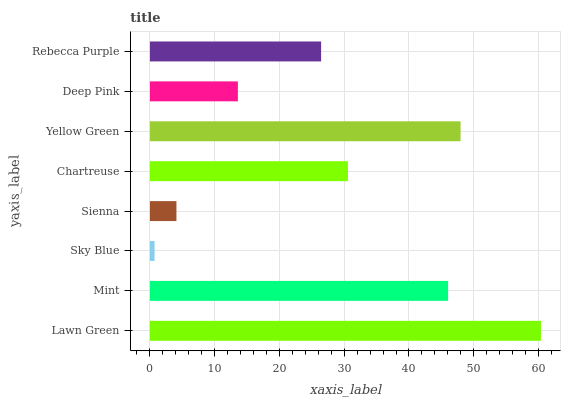Is Sky Blue the minimum?
Answer yes or no. Yes. Is Lawn Green the maximum?
Answer yes or no. Yes. Is Mint the minimum?
Answer yes or no. No. Is Mint the maximum?
Answer yes or no. No. Is Lawn Green greater than Mint?
Answer yes or no. Yes. Is Mint less than Lawn Green?
Answer yes or no. Yes. Is Mint greater than Lawn Green?
Answer yes or no. No. Is Lawn Green less than Mint?
Answer yes or no. No. Is Chartreuse the high median?
Answer yes or no. Yes. Is Rebecca Purple the low median?
Answer yes or no. Yes. Is Lawn Green the high median?
Answer yes or no. No. Is Deep Pink the low median?
Answer yes or no. No. 